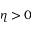<formula> <loc_0><loc_0><loc_500><loc_500>\eta > 0</formula> 